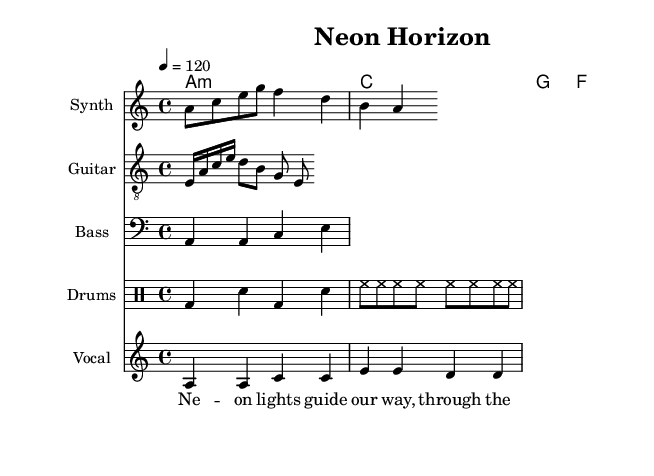What is the key signature of this music? The key signature is A minor, which has no sharps or flats.
Answer: A minor What is the time signature of this music? The time signature is identified by the fraction at the beginning; in this case, it is 4/4, indicating four beats per measure.
Answer: 4/4 What is the tempo marking for this piece? The tempo marking indicates the speed of the music; here it is specified as a quarter note equals 120 beats per minute.
Answer: 120 How many measures are in the melody? By counting the note groups in the synth melody, there are eight distinct note values (indicators of measures) when considering rhythmic patterns, leading to a total of two measures.
Answer: 2 measures Which instrument plays the main melody? The main melody is written in the staff labeled "Synth," indicating that this instrument carries the primary melodic line for the piece.
Answer: Synth What type of rhythmic pattern is used for the drums? The drum pattern consists of a combination of bass and snare hits, along with hi-hat cymbals, representing a typical electronic drum rhythm.
Answer: Electronic drum pattern In which section do the lyrics appear? The lyrics are placed below the staff for "Vocals" in the sheet music, indicating the specific section for vocal parts.
Answer: Vocals 